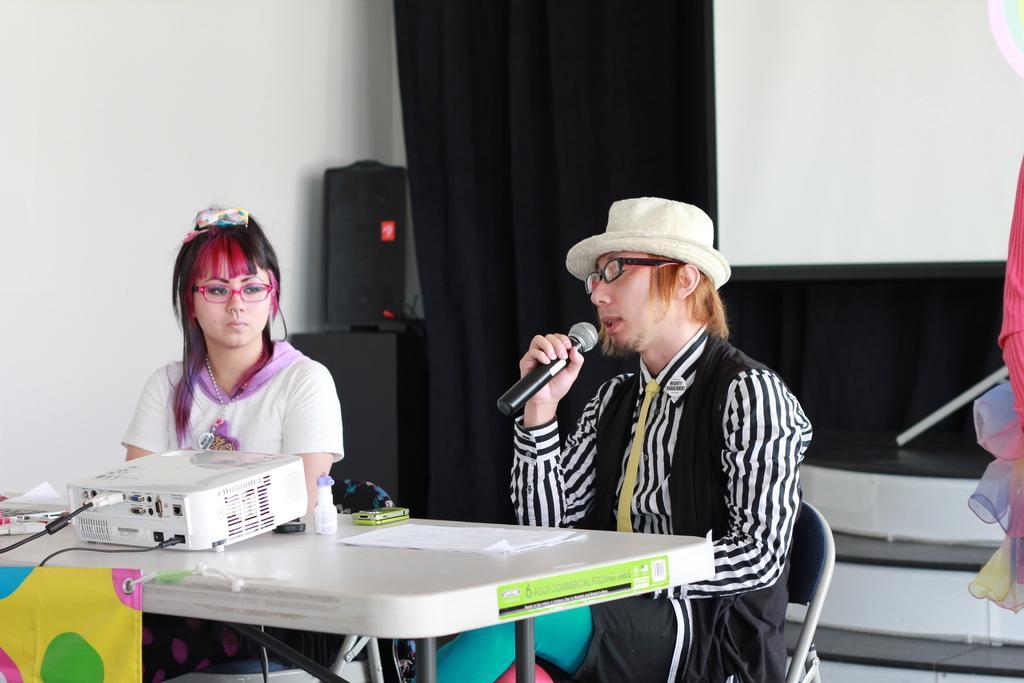Could you give a brief overview of what you see in this image? In the image we can see two people sitting, wearing clothes and spectacles, the right side person is holding a microphone and wearing a cap, and it looks like the person is talking. Here we can see the table, on the table, we can see the electronic device, papers and other objects. Here we can see chairs, curtains and the wall. 